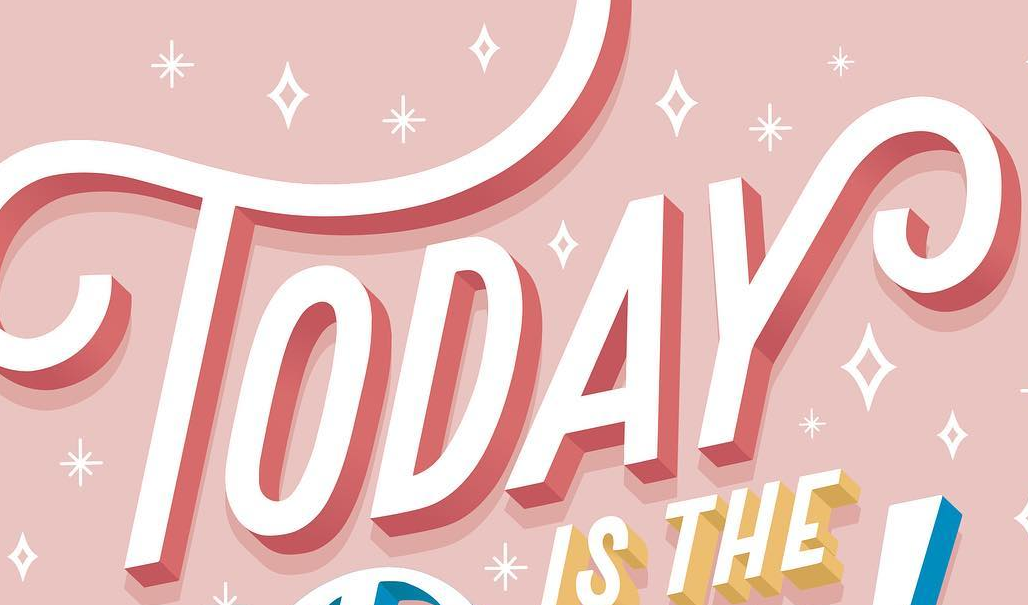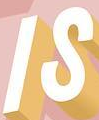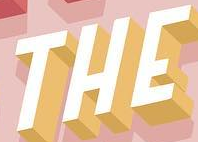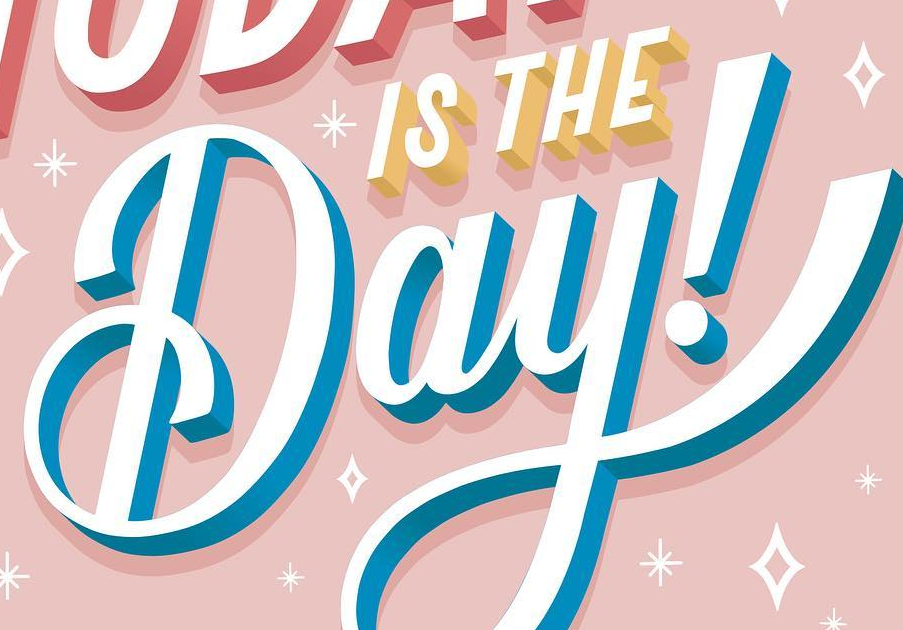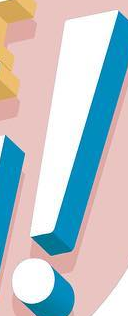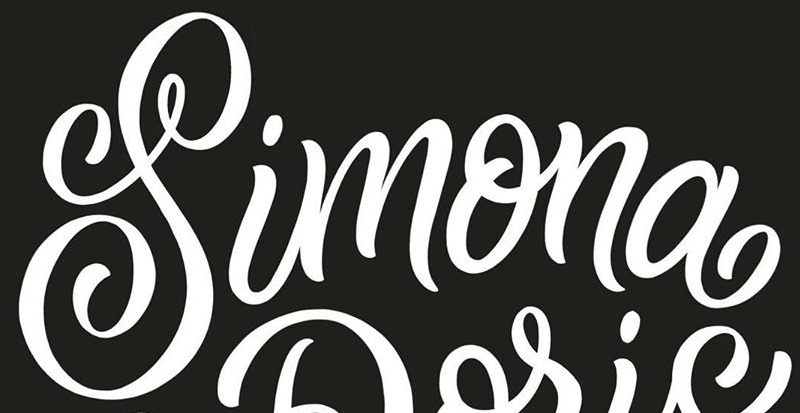What words can you see in these images in sequence, separated by a semicolon? TODAY; IS; THE; Day; !; Simona 